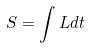<formula> <loc_0><loc_0><loc_500><loc_500>S = \int L d t</formula> 